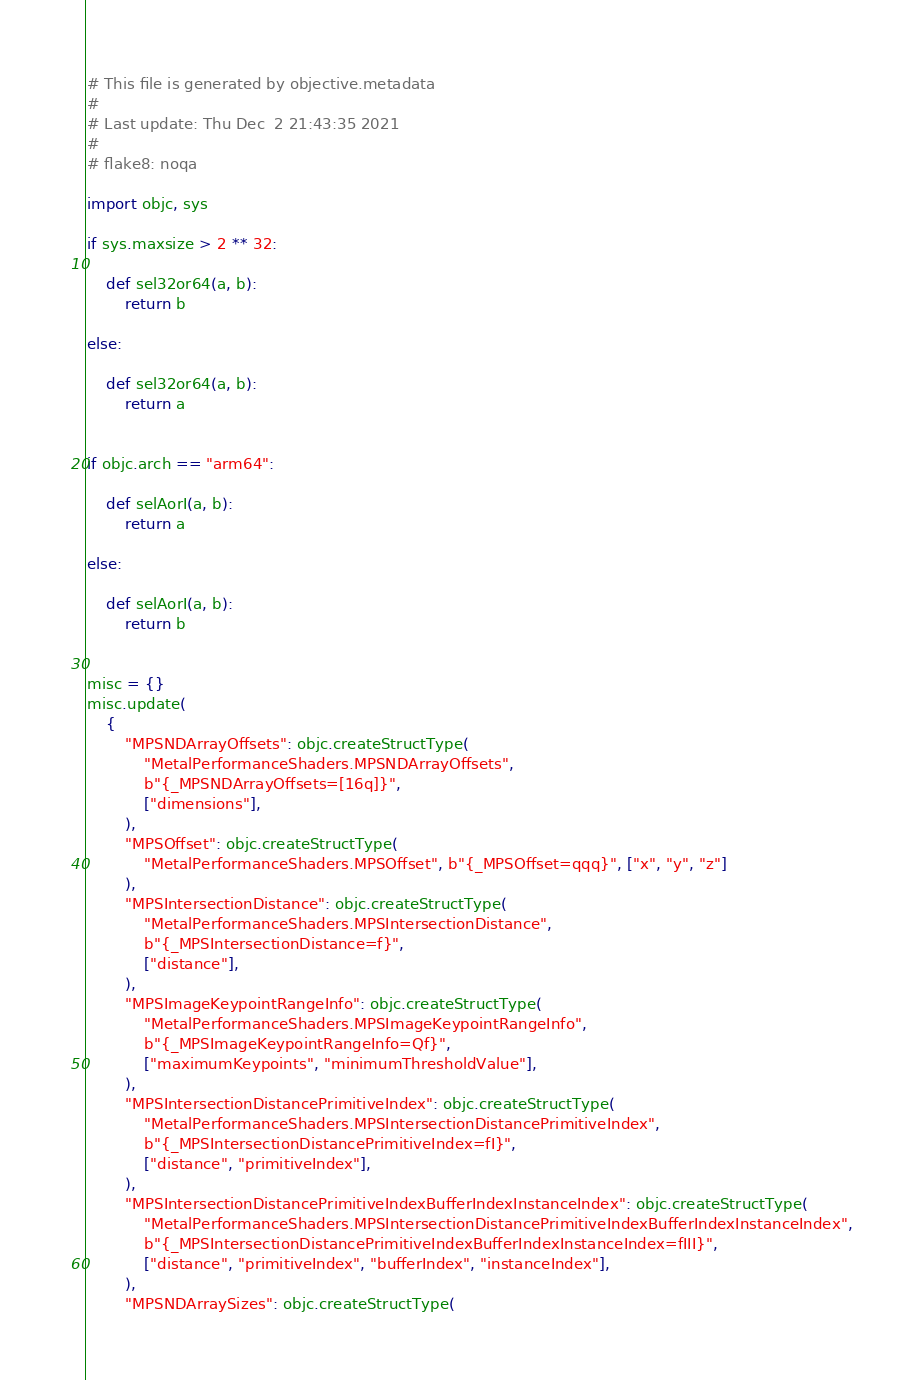Convert code to text. <code><loc_0><loc_0><loc_500><loc_500><_Python_># This file is generated by objective.metadata
#
# Last update: Thu Dec  2 21:43:35 2021
#
# flake8: noqa

import objc, sys

if sys.maxsize > 2 ** 32:

    def sel32or64(a, b):
        return b

else:

    def sel32or64(a, b):
        return a


if objc.arch == "arm64":

    def selAorI(a, b):
        return a

else:

    def selAorI(a, b):
        return b


misc = {}
misc.update(
    {
        "MPSNDArrayOffsets": objc.createStructType(
            "MetalPerformanceShaders.MPSNDArrayOffsets",
            b"{_MPSNDArrayOffsets=[16q]}",
            ["dimensions"],
        ),
        "MPSOffset": objc.createStructType(
            "MetalPerformanceShaders.MPSOffset", b"{_MPSOffset=qqq}", ["x", "y", "z"]
        ),
        "MPSIntersectionDistance": objc.createStructType(
            "MetalPerformanceShaders.MPSIntersectionDistance",
            b"{_MPSIntersectionDistance=f}",
            ["distance"],
        ),
        "MPSImageKeypointRangeInfo": objc.createStructType(
            "MetalPerformanceShaders.MPSImageKeypointRangeInfo",
            b"{_MPSImageKeypointRangeInfo=Qf}",
            ["maximumKeypoints", "minimumThresholdValue"],
        ),
        "MPSIntersectionDistancePrimitiveIndex": objc.createStructType(
            "MetalPerformanceShaders.MPSIntersectionDistancePrimitiveIndex",
            b"{_MPSIntersectionDistancePrimitiveIndex=fI}",
            ["distance", "primitiveIndex"],
        ),
        "MPSIntersectionDistancePrimitiveIndexBufferIndexInstanceIndex": objc.createStructType(
            "MetalPerformanceShaders.MPSIntersectionDistancePrimitiveIndexBufferIndexInstanceIndex",
            b"{_MPSIntersectionDistancePrimitiveIndexBufferIndexInstanceIndex=fIII}",
            ["distance", "primitiveIndex", "bufferIndex", "instanceIndex"],
        ),
        "MPSNDArraySizes": objc.createStructType(</code> 